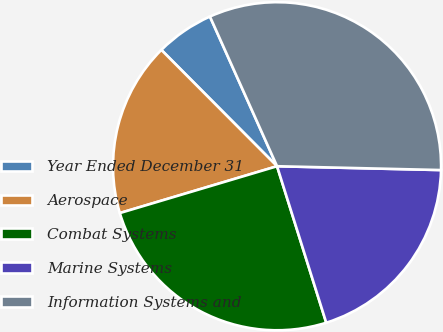Convert chart to OTSL. <chart><loc_0><loc_0><loc_500><loc_500><pie_chart><fcel>Year Ended December 31<fcel>Aerospace<fcel>Combat Systems<fcel>Marine Systems<fcel>Information Systems and<nl><fcel>5.75%<fcel>17.15%<fcel>25.24%<fcel>19.78%<fcel>32.08%<nl></chart> 